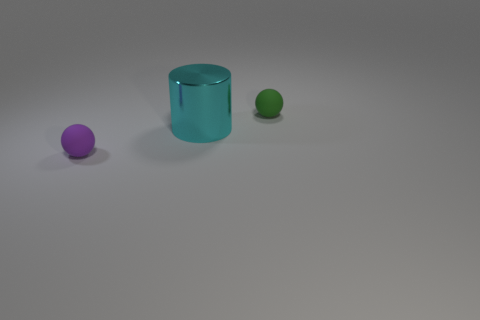There is a small rubber ball that is on the right side of the cyan metal cylinder; how many small balls are in front of it? In the image, there is one small green ball located directly in front of the cyan metal cylinder, positioned closer to the viewer than the cylinder. Additionally, there's another small purple ball to the left side of the cylinder, though not directly in front of it. Therefore, there is 1 small ball directly in front of the cyan cylinder. 